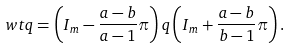<formula> <loc_0><loc_0><loc_500><loc_500>\ w t q = \left ( I _ { m } - \frac { a - b } { a - 1 } \pi \right ) q \left ( I _ { m } + \frac { a - b } { b - 1 } \pi \right ) .</formula> 